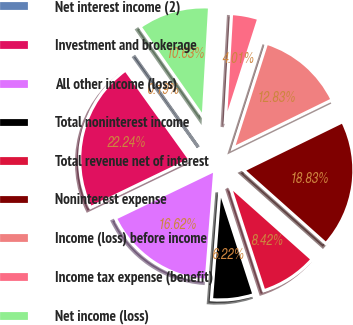<chart> <loc_0><loc_0><loc_500><loc_500><pie_chart><fcel>Net interest income (2)<fcel>Investment and brokerage<fcel>All other income (loss)<fcel>Total noninterest income<fcel>Total revenue net of interest<fcel>Noninterest expense<fcel>Income (loss) before income<fcel>Income tax expense (benefit)<fcel>Net income (loss)<nl><fcel>0.19%<fcel>22.24%<fcel>16.62%<fcel>6.22%<fcel>8.42%<fcel>18.83%<fcel>12.83%<fcel>4.01%<fcel>10.63%<nl></chart> 